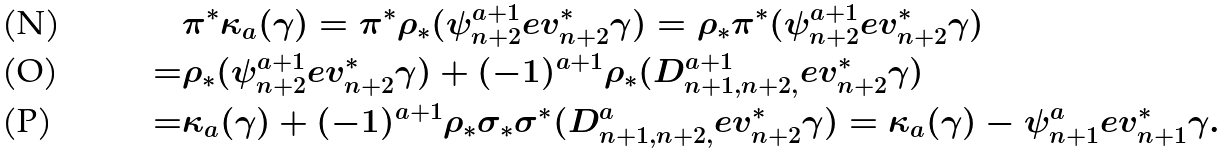Convert formula to latex. <formula><loc_0><loc_0><loc_500><loc_500>& \pi ^ { * } \kappa _ { a } ( \gamma ) = \pi ^ { * } \rho _ { * } ( \psi _ { n + 2 } ^ { a + 1 } e v _ { n + 2 } ^ { * } \gamma ) = \rho _ { * } \pi ^ { * } ( \psi _ { n + 2 } ^ { a + 1 } e v _ { n + 2 } ^ { * } \gamma ) \\ = & \rho _ { * } ( \psi _ { n + 2 } ^ { a + 1 } e v _ { n + 2 } ^ { * } \gamma ) + ( - 1 ) ^ { a + 1 } \rho _ { * } ( D _ { n + 1 , n + 2 , } ^ { a + 1 } e v _ { n + 2 } ^ { * } \gamma ) \\ = & \kappa _ { a } ( \gamma ) + ( - 1 ) ^ { a + 1 } \rho _ { * } \sigma _ { * } \sigma ^ { * } ( D _ { n + 1 , n + 2 , } ^ { a } e v _ { n + 2 } ^ { * } \gamma ) = \kappa _ { a } ( \gamma ) - \psi _ { n + 1 } ^ { a } e v _ { n + 1 } ^ { * } \gamma .</formula> 